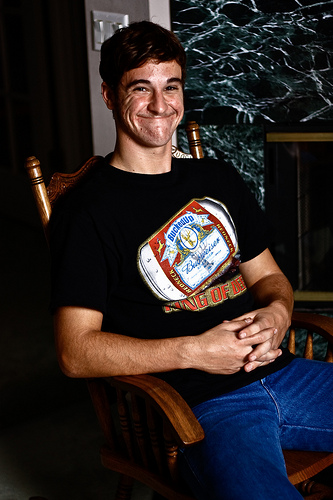<image>
Is the shirt in front of the wall? Yes. The shirt is positioned in front of the wall, appearing closer to the camera viewpoint. 